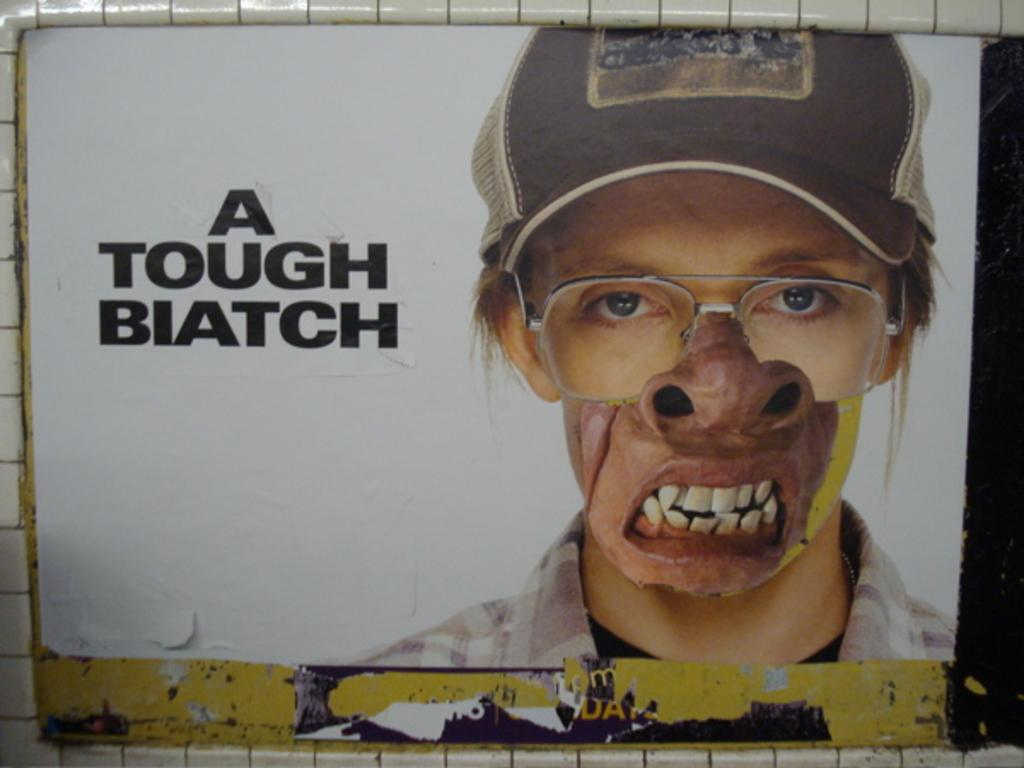What is depicted on the poster in the image? The poster contains a human image. What else can be found on the poster besides the human image? There is text on the poster. How many matches are visible on the poster? There are no matches present on the poster; it contains a human image and text. 